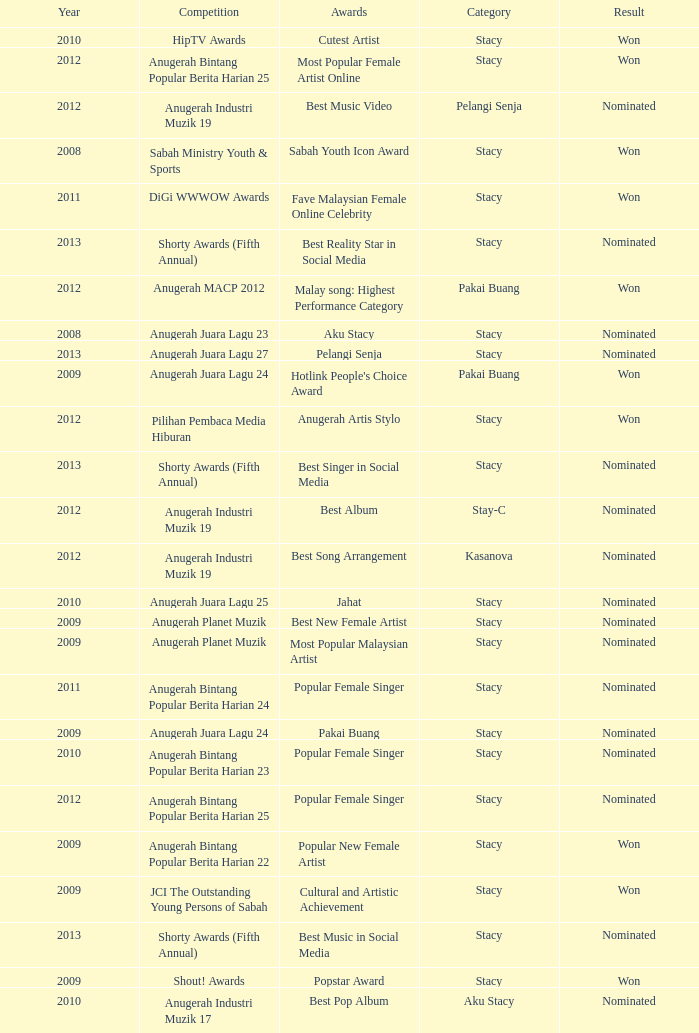What was the year that had Anugerah Bintang Popular Berita Harian 23 as competition? 1.0. 